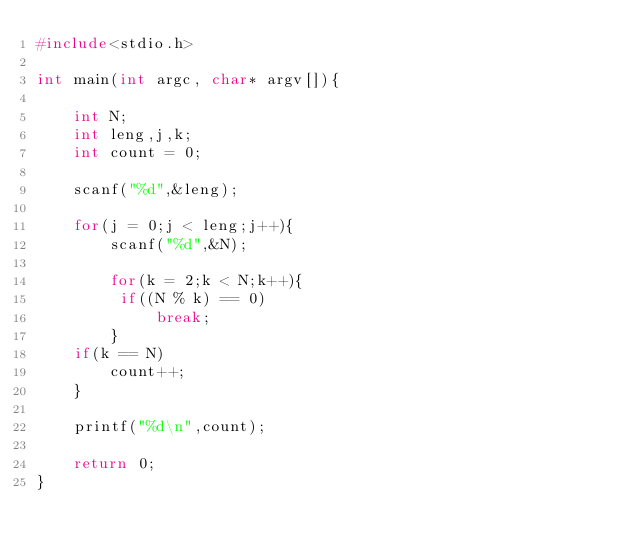<code> <loc_0><loc_0><loc_500><loc_500><_C_>#include<stdio.h>

int main(int argc, char* argv[]){

	int N;
	int leng,j,k;
	int count = 0;

	scanf("%d",&leng);

	for(j = 0;j < leng;j++){
		scanf("%d",&N);

		for(k = 2;k < N;k++){
         if((N % k) == 0)
			 break;
		}
    if(k == N)
		count++;
	}

	printf("%d\n",count);

	return 0;
}	</code> 